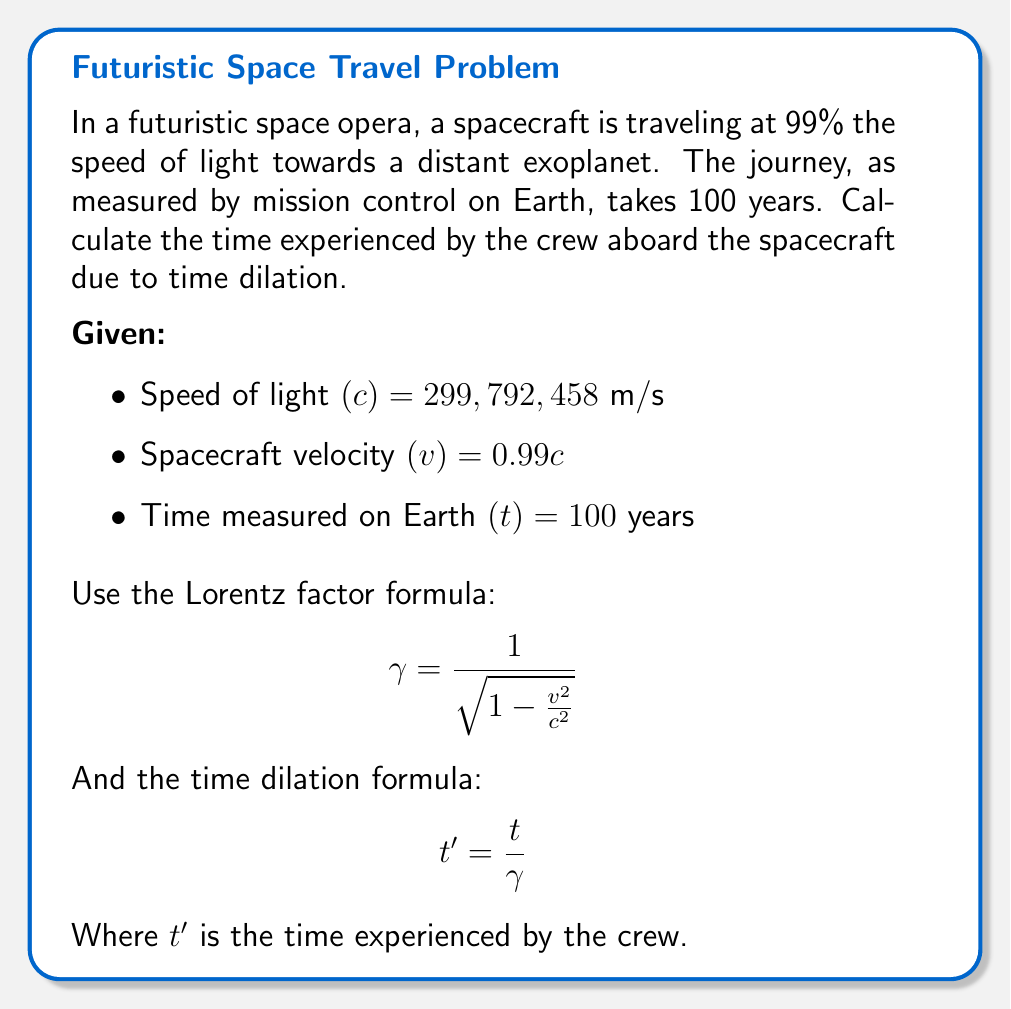Help me with this question. 1. Calculate the Lorentz factor ($\gamma$):
   $$\gamma = \frac{1}{\sqrt{1 - \frac{v^2}{c^2}}} = \frac{1}{\sqrt{1 - \frac{(0.99c)^2}{c^2}}} = \frac{1}{\sqrt{1 - 0.99^2}} \approx 7.0888$$

2. Use the time dilation formula to calculate the time experienced by the crew:
   $$t' = \frac{t}{\gamma} = \frac{100 \text{ years}}{7.0888} \approx 14.1068 \text{ years}$$

3. Round the result to two decimal places:
   $14.11$ years

The crew experiences significantly less time due to relativistic effects, demonstrating the dramatic impact of time dilation at speeds approaching the speed of light.
Answer: 14.11 years 